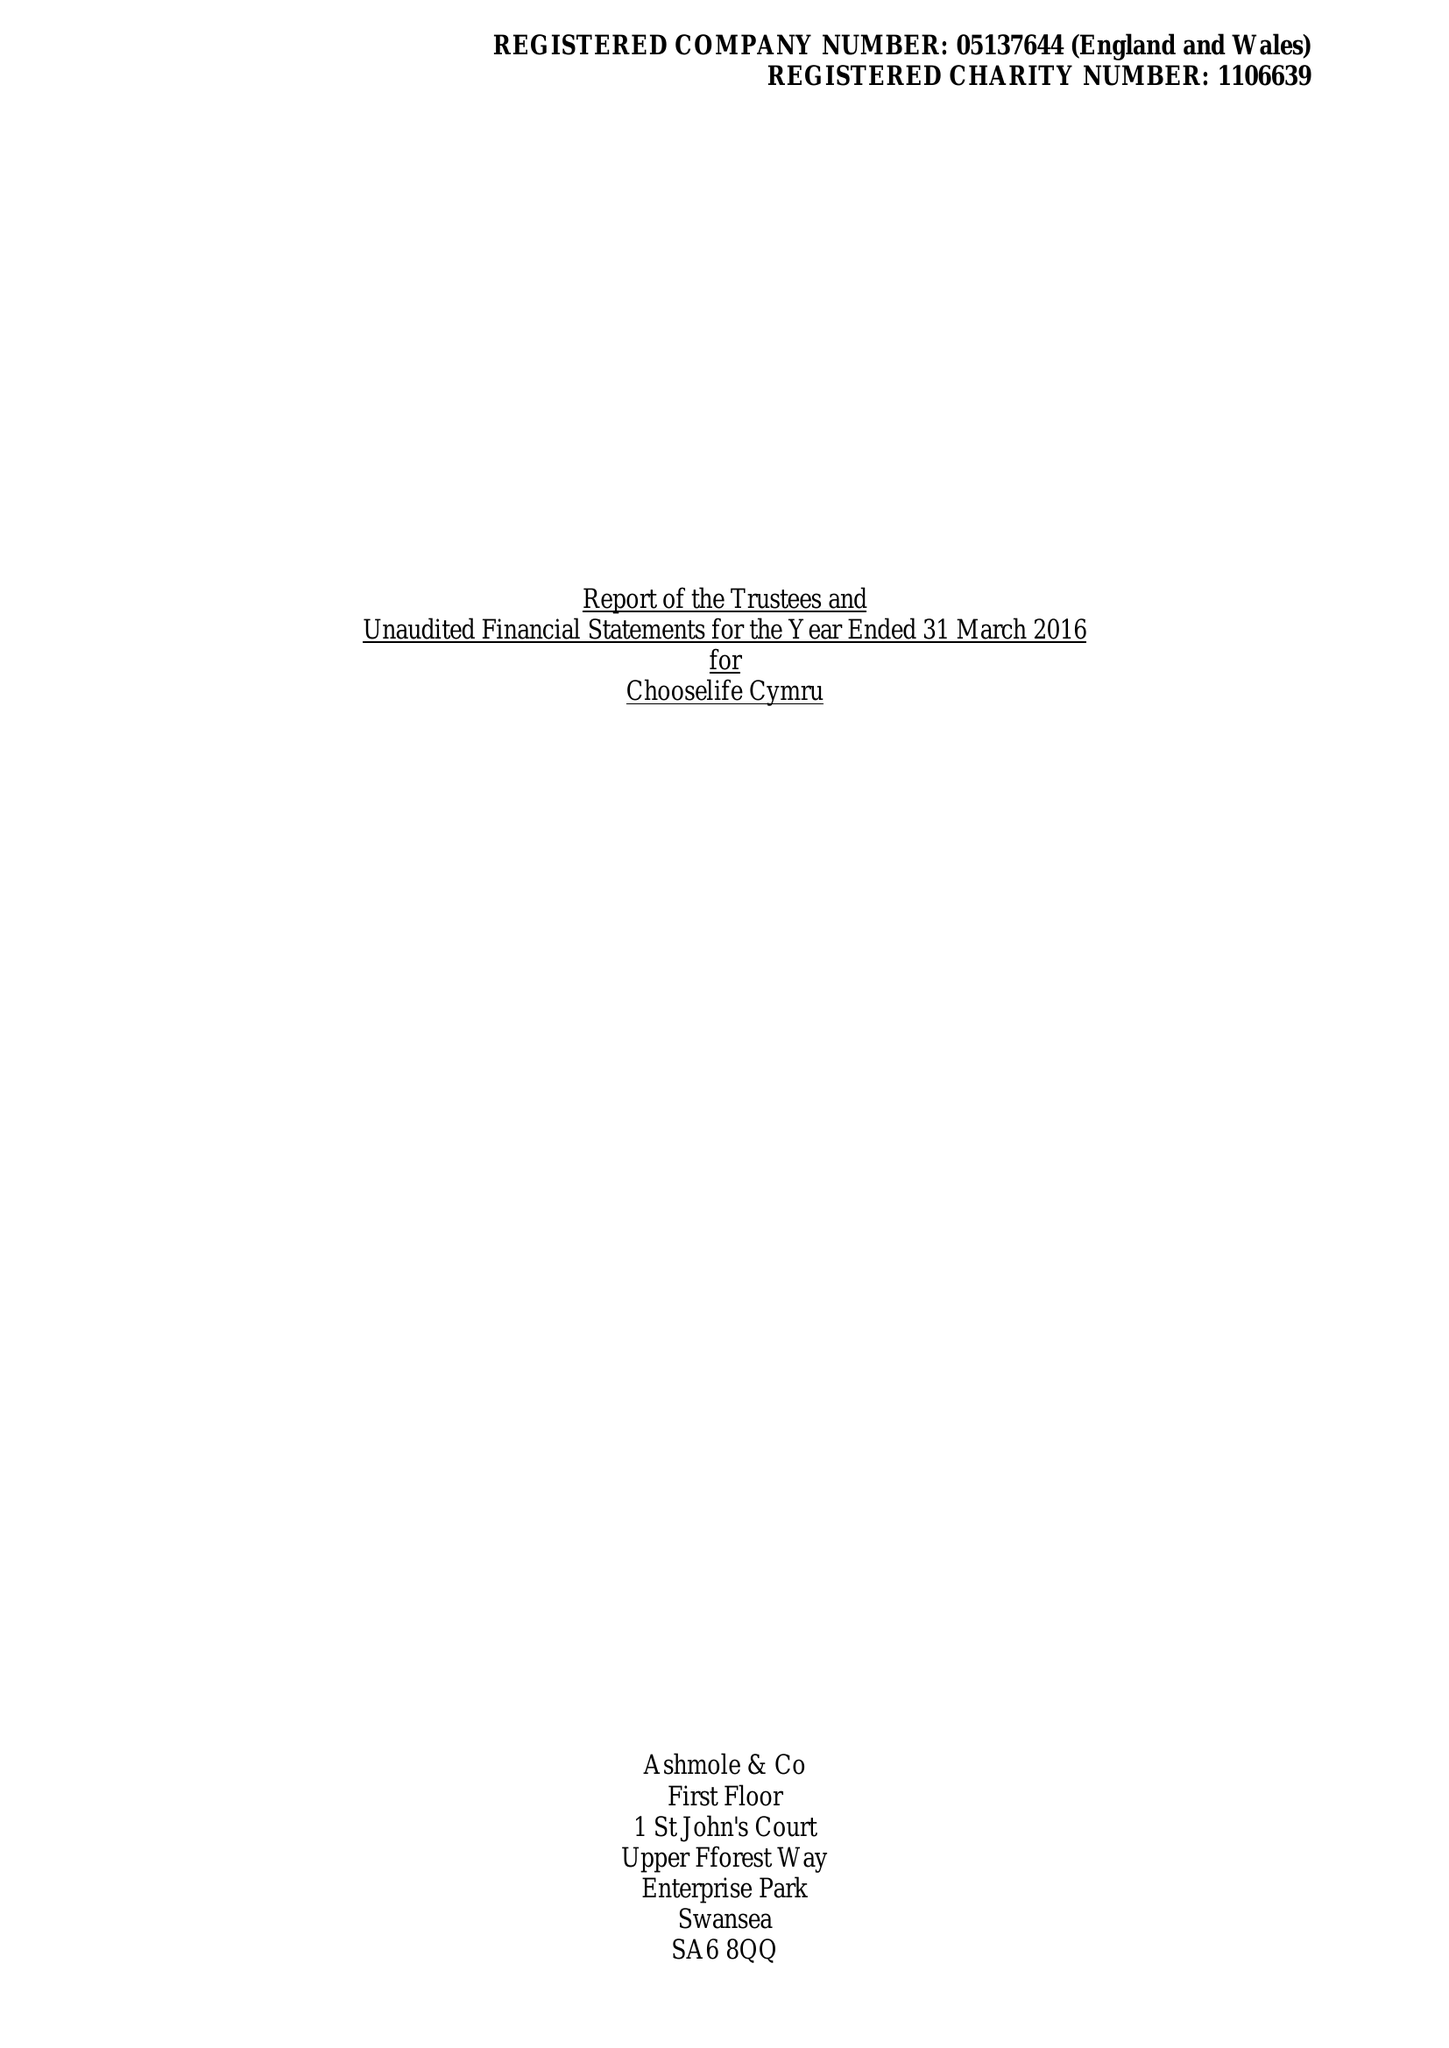What is the value for the spending_annually_in_british_pounds?
Answer the question using a single word or phrase. 372379.00 